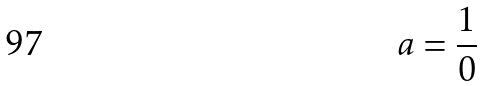<formula> <loc_0><loc_0><loc_500><loc_500>a = \frac { 1 } { 0 }</formula> 